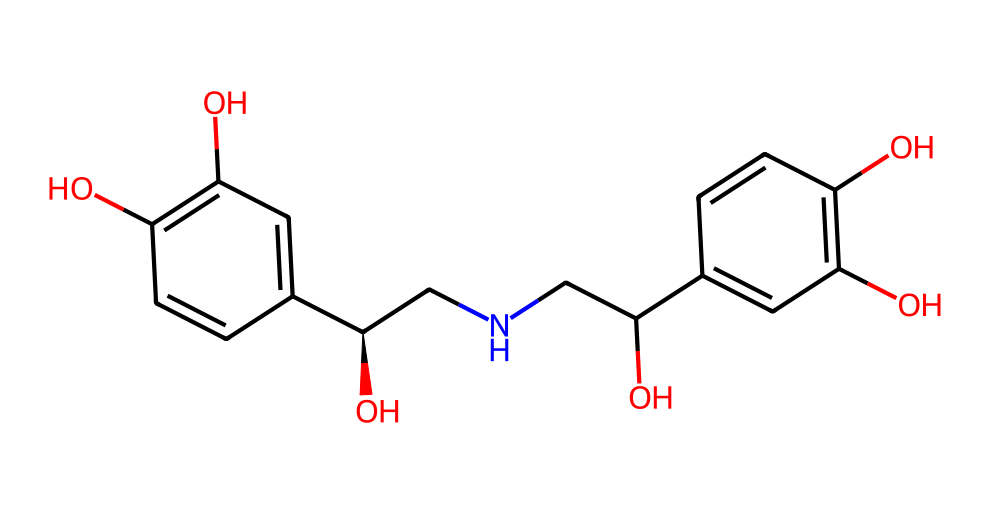What is the primary chemical feature that indicates this molecule is a hormone? The presence of hydroxyl (-OH) groups suggests that this molecule has hormonal properties, as many hormones contain hydroxyl groups that affect their solubility and function in biological systems.
Answer: hydroxyl groups How many hydroxyl groups are present in the chemical structure? By examining the structure, we can identify three distinct -OH groups, which are characteristic of hormones as they often participate in reaction mechanisms and biological activities.
Answer: three What type of biological effect does adrenaline primarily induce? Adrenaline primarily induces a fight-or-flight response, which involves increased heart rate and energy availability in response to stress, primarily mediated by its interaction with adrenergic receptors.
Answer: fight-or-flight response How many benzene rings can be observed in this structure? This molecule has two distinct aromatic rings, which indicates its structural complexity and aligns with many hormones that have multiple ring systems for bioactivity.
Answer: two What is the molecular formula derived from this compound based on the structure? Analyzing the atoms in this structure reveals a molecular formula of C18H22N2O4, encapsulating the compound's composition and aiding in its identification as adrenaline.
Answer: C18H22N2O4 What role does the amine group play in the function of adrenaline? The amine group in this molecule contributes to its ability to bind to adrenergic receptors, thereby enhancing its biological activity and interaction within biological systems, which is crucial for its hormonal action.
Answer: binding to receptors Which functional groups are primarily responsible for making this molecule polar? The hydroxyl (-OH) and amine (-NH) groups contribute to the polarity of adrenaline, influencing its solubility in aqueous environments and its behavior in physiological conditions.
Answer: hydroxyl and amine groups 